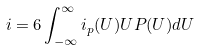<formula> <loc_0><loc_0><loc_500><loc_500>i = 6 \int _ { - \infty } ^ { \infty } i _ { p } ( U ) U P ( U ) d U</formula> 